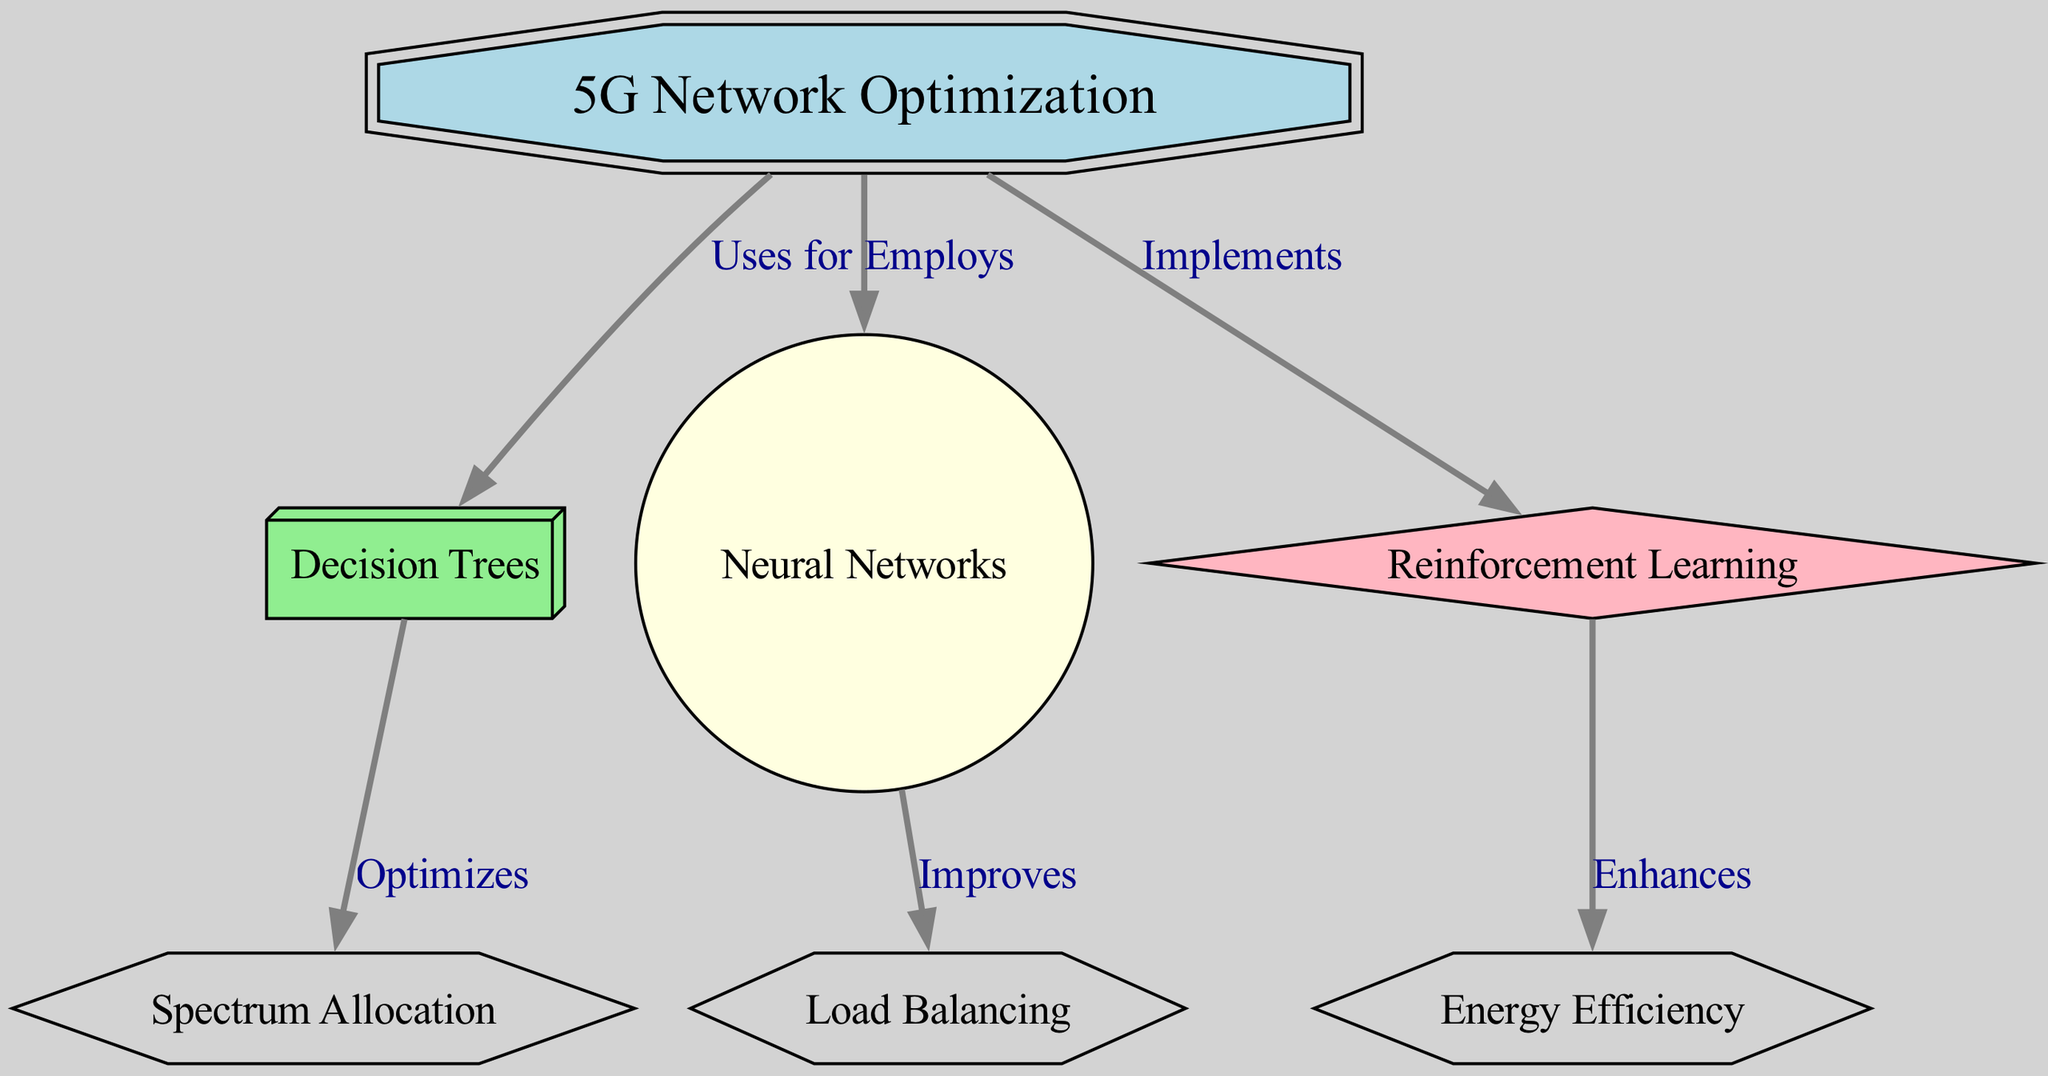What is the overall focus of the diagram? The diagram is centered on the optimization of the 5G Network, as indicated by the main node labeled "5G Network Optimization". Its position at the top emphasizes its significance in the diagram.
Answer: 5G Network Optimization How many nodes are present in the diagram? Counting all the unique nodes listed in the diagram, we find seven: "5G Network", "Decision Trees", "Neural Networks", "Reinforcement Learning", "Spectrum Allocation", "Load Balancing", and "Energy Efficiency".
Answer: 7 Which machine learning model is associated with enhancing energy efficiency? The edge connecting "Reinforcement Learning" to "Energy Efficiency" indicates that this model is specifically applied to enhance energy efficiency in the context of 5G network optimization.
Answer: Reinforcement Learning What aspect does the "Decision Trees" node optimize? The connection from "Decision Trees" to "Spectrum Allocation" shows that decision trees are specifically used to optimize spectrum allocation within the 5G network.
Answer: Spectrum Allocation Which model improves load balancing? The diagram indicates that "Neural Networks" improve "Load Balancing", as shown by the directed edge between these two nodes.
Answer: Neural Networks How many edges are present in the diagram? By examining each line that connects pairs of nodes in the diagram, we identify six directed edges: they describe the relationships among the various machine learning models and the aspects they optimize.
Answer: 6 Which machine learning approach employs decision trees? The edge from "5G Network" to "Decision Trees" signifies that the overall optimization effort within the 5G network employs this machine learning technique.
Answer: Decision Trees Which machine learning model relates to load balancing and energy efficiency? The diagram shows two different models connected to different aspects: "Neural Networks" is related to "Load Balancing", and "Reinforcement Learning" is related to "Energy Efficiency". Therefore, they are distinct but both are important for different optimizations.
Answer: Neural Networks and Reinforcement Learning What relationship does "Neural Networks" have with "Load Balancing"? The edge labeled "Improves" connects "Neural Networks" to "Load Balancing", indicating that neural networks play an important role in enhancing load balancing in the network.
Answer: Improves 